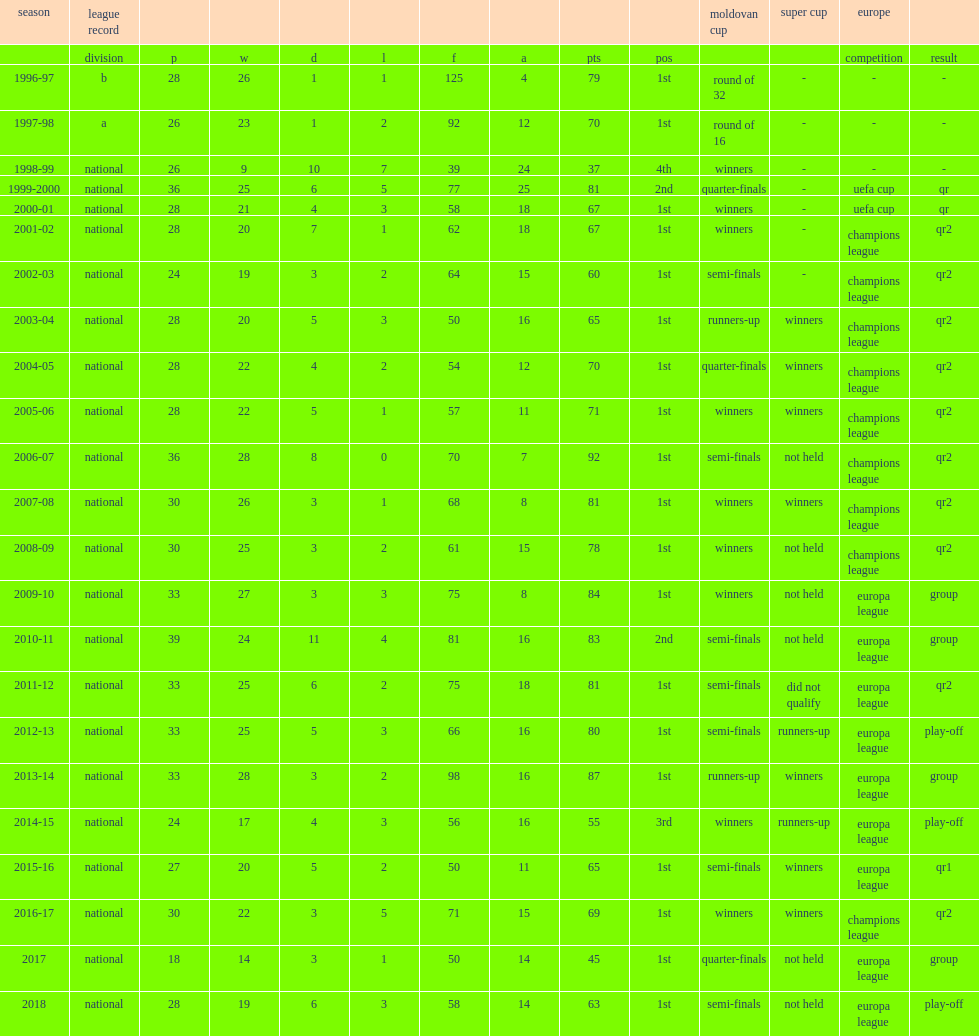What was the rank of moldovan national division sheriff in 2010-11? 2nd. 